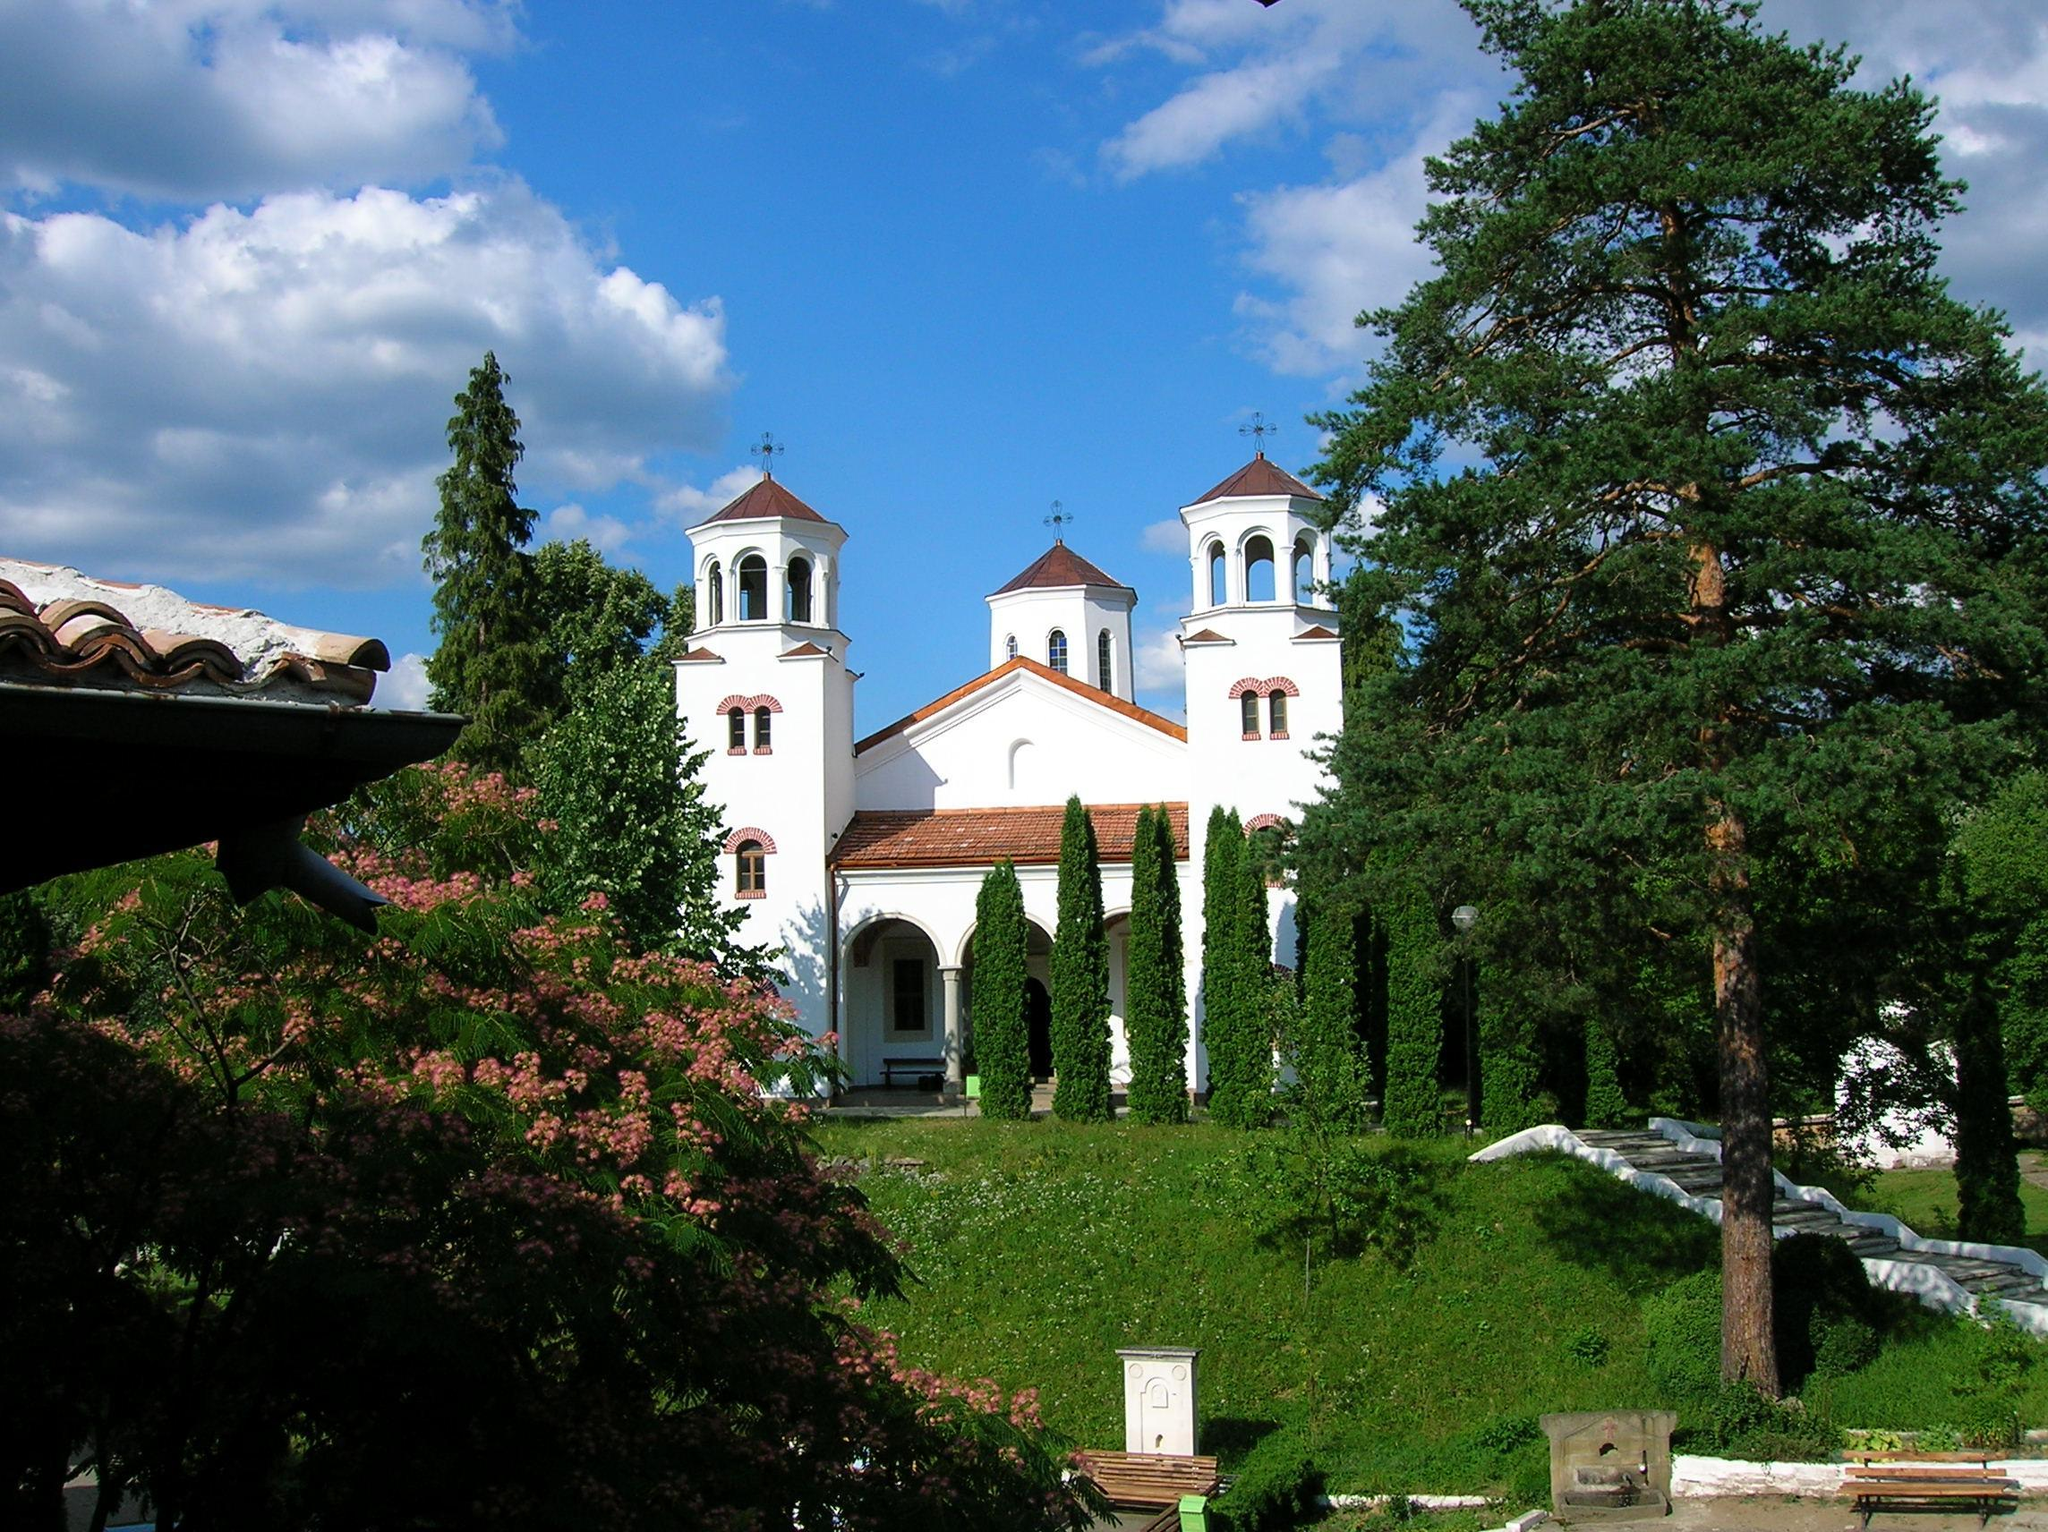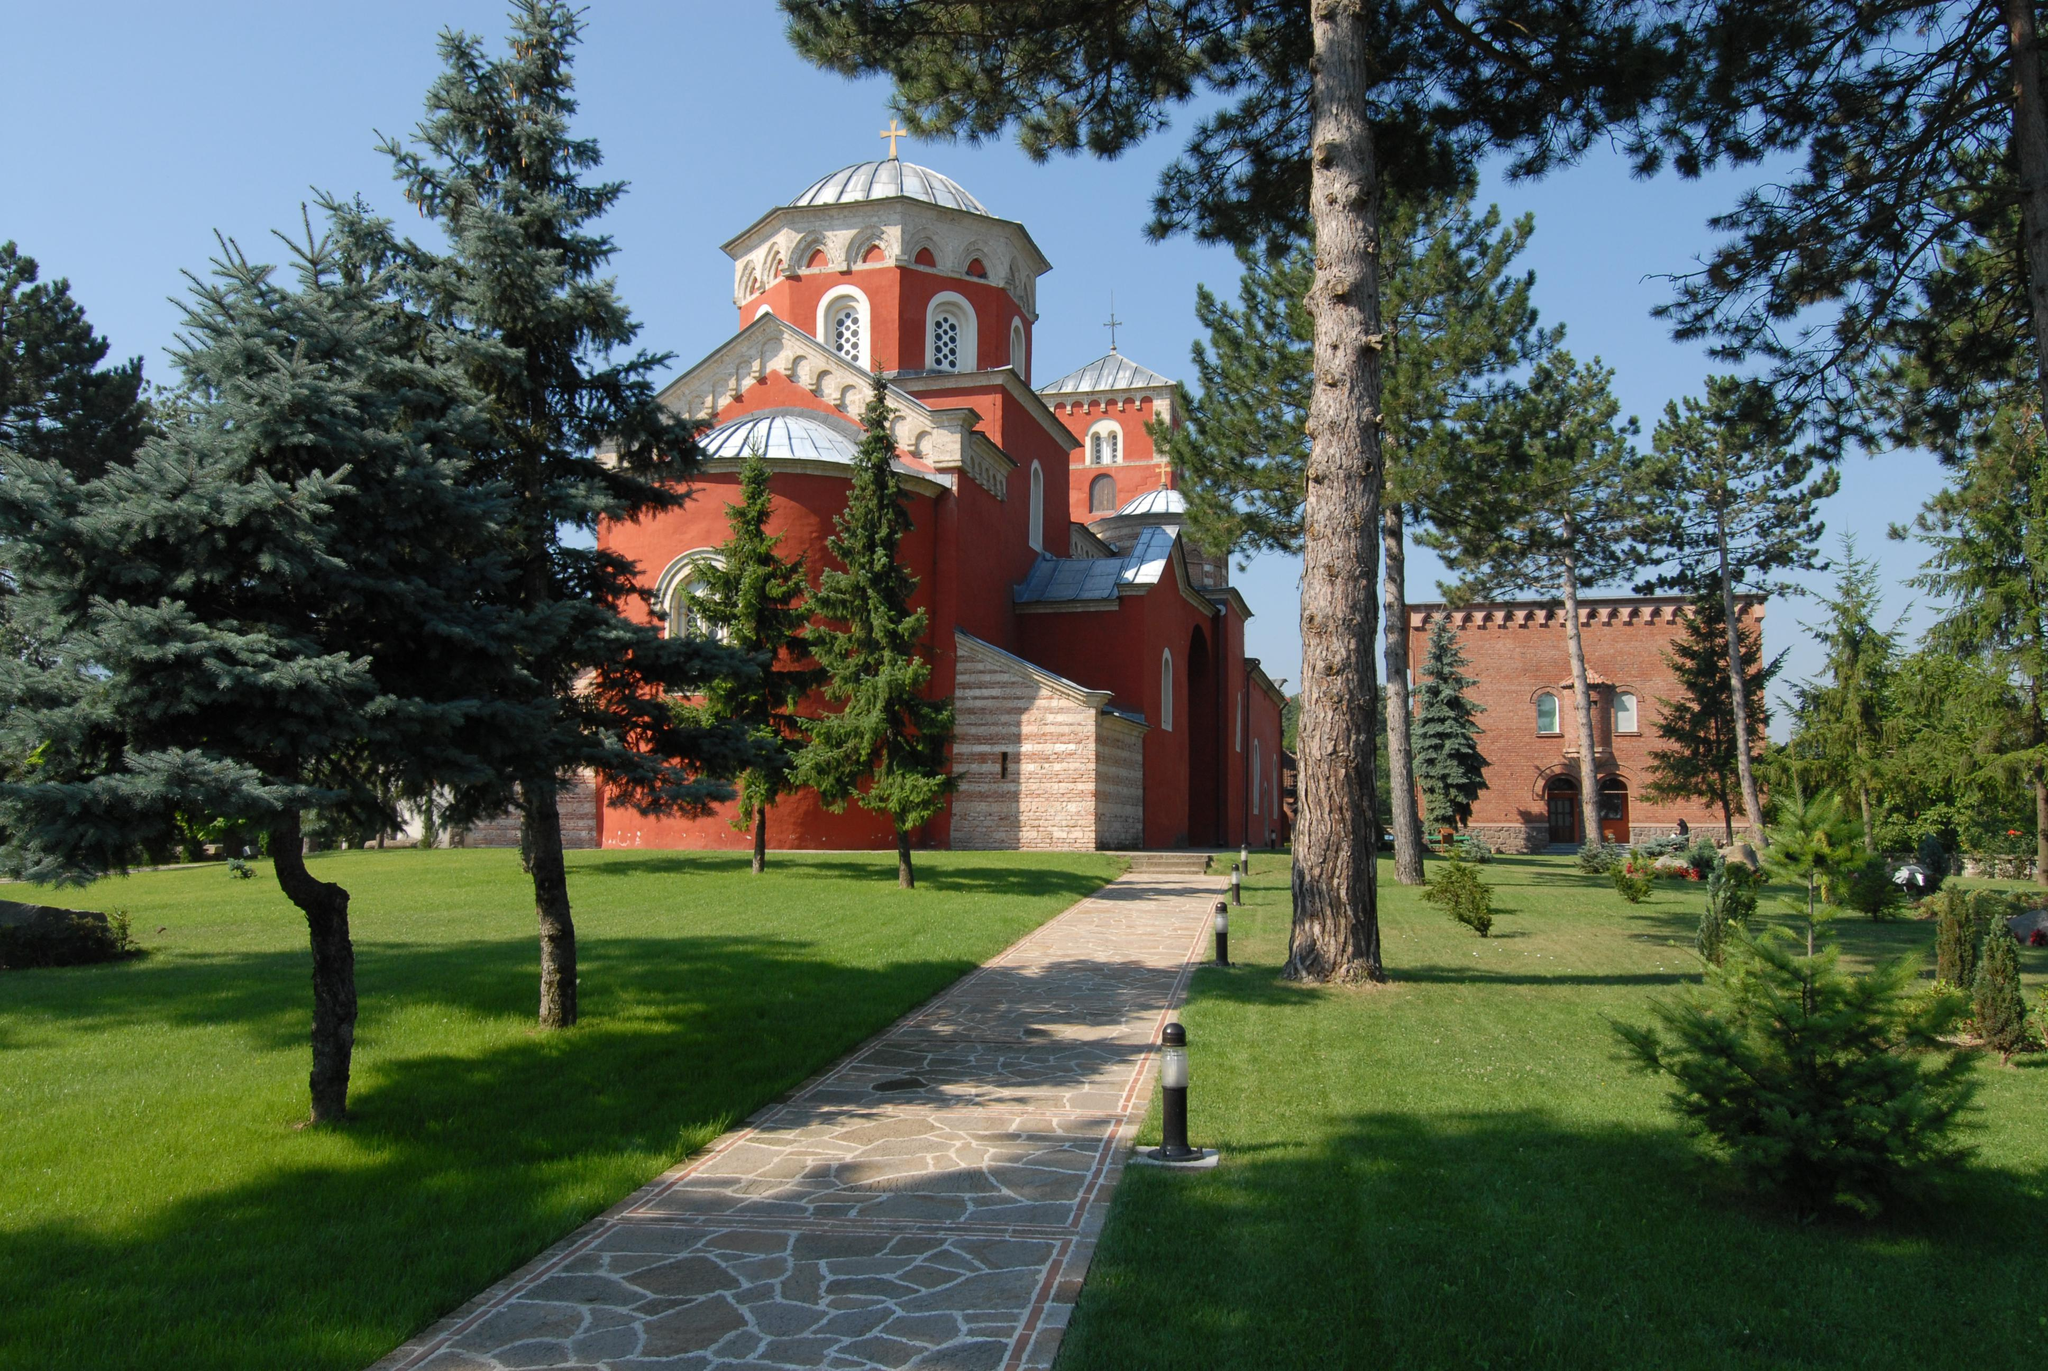The first image is the image on the left, the second image is the image on the right. Evaluate the accuracy of this statement regarding the images: "Both images show a sprawling red-orange building with at least one cross-topped dome roof and multiple arch windows.". Is it true? Answer yes or no. No. The first image is the image on the left, the second image is the image on the right. For the images displayed, is the sentence "One of the images shows a long narrow paved path leading to an orange building with a cross atop." factually correct? Answer yes or no. Yes. 